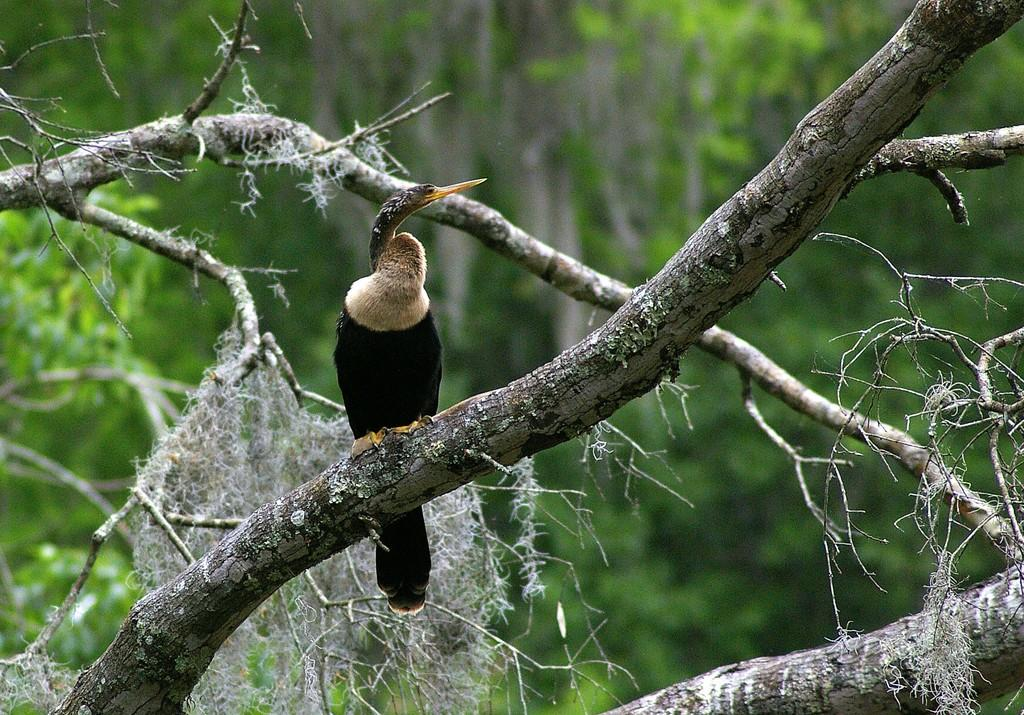What type of animal can be seen in the image? There is a bird in the image. Where is the bird located? The bird is on the stem of a tree. What can be seen in the background of the image? There are trees in the background of the image. What type of cover does the bird use to protect itself from the sun in the image? There is no cover visible in the image, and the bird's actions are not described. 